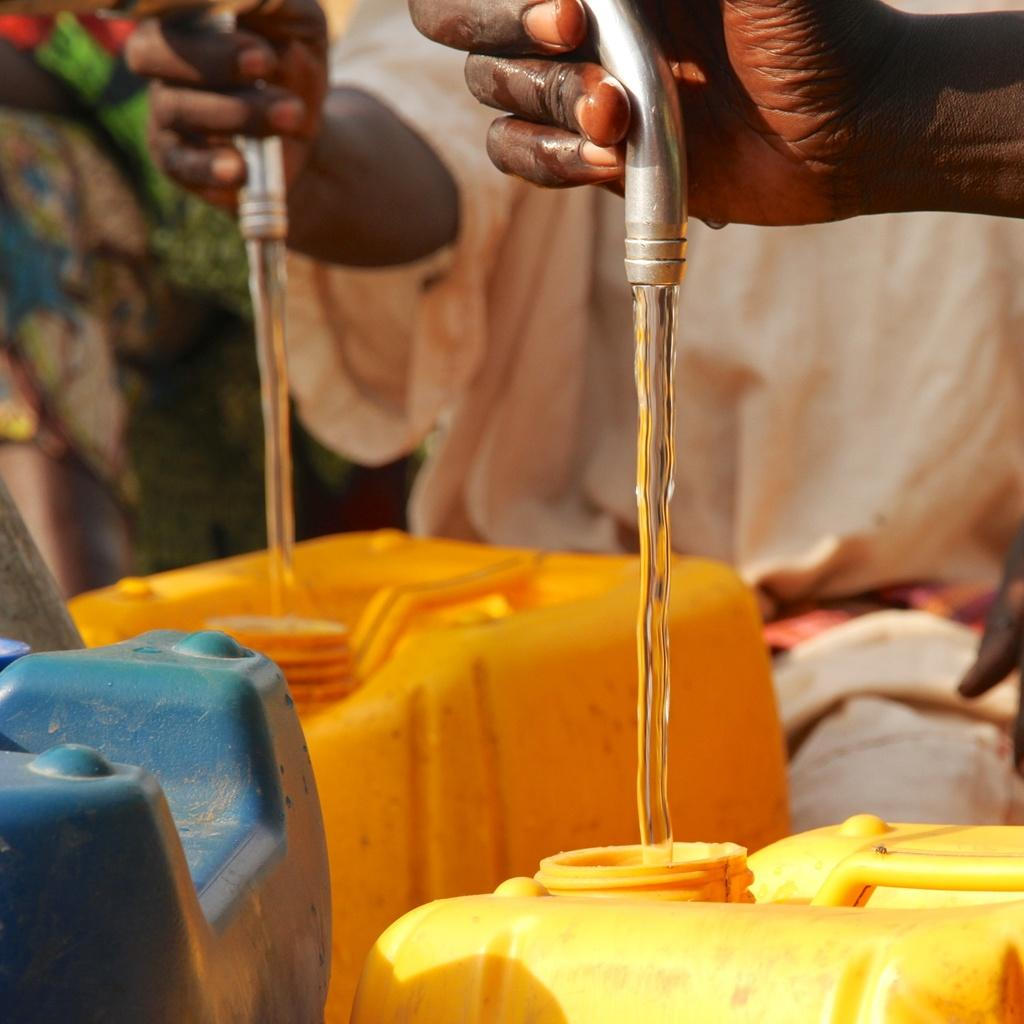How many people are in the image? There are two people in the image. What are the people doing with their hands? The hands of the two people are holding pipes. What is happening with the pipes? Liquid is flowing from the pipes. What are the cans at the bottom used for? The liquid is flowing into the cans. Is there a beggar in the image? There is no beggar present in the image. 